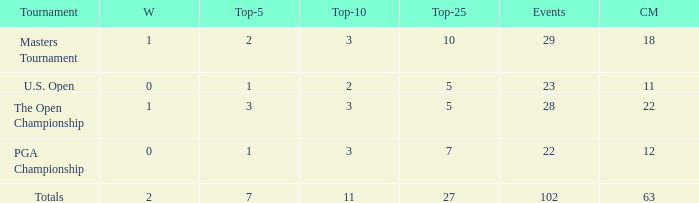How many top 10s associated with 3 top 5s and under 22 cuts made? None. 